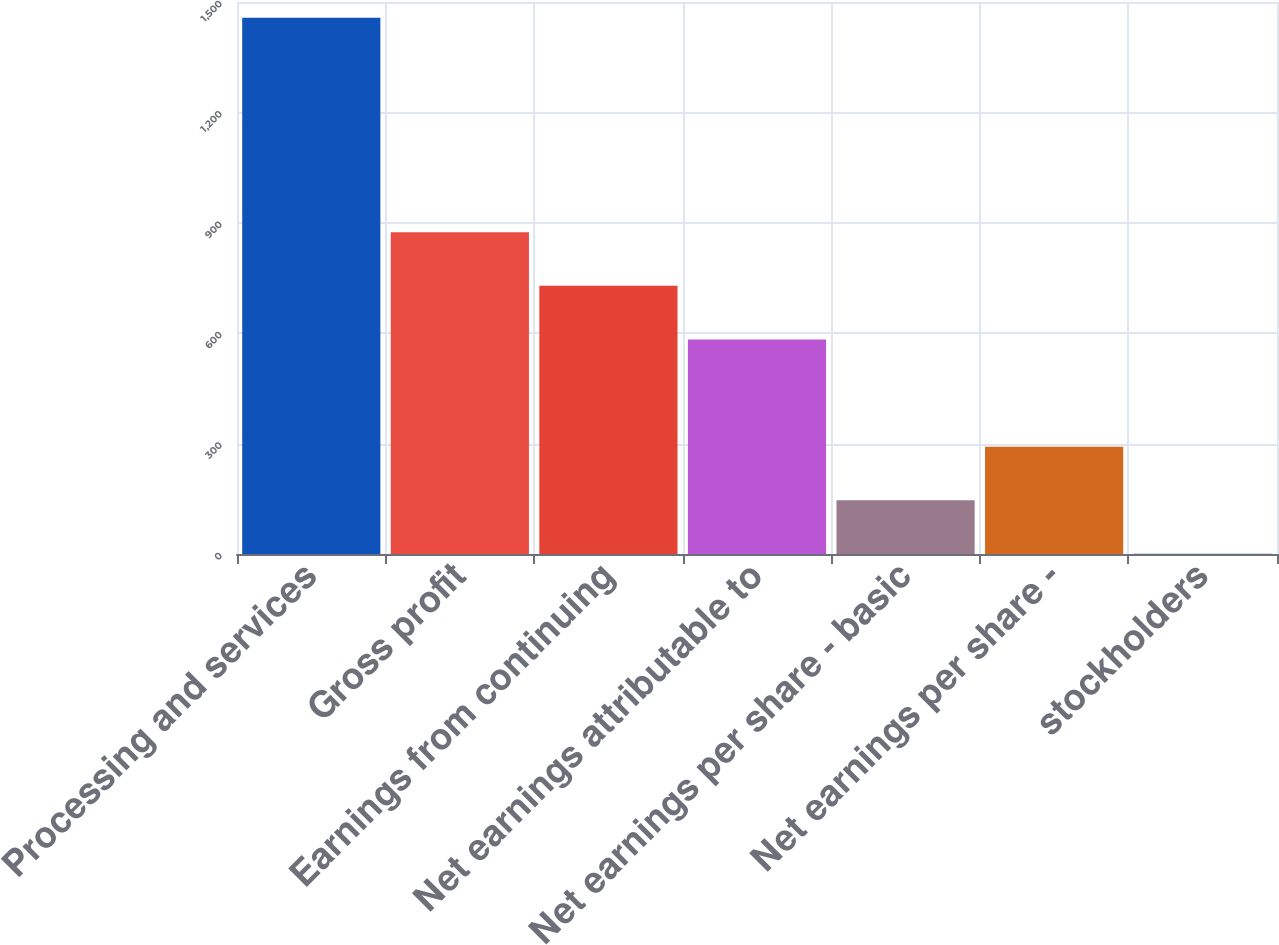Convert chart. <chart><loc_0><loc_0><loc_500><loc_500><bar_chart><fcel>Processing and services<fcel>Gross profit<fcel>Earnings from continuing<fcel>Net earnings attributable to<fcel>Net earnings per share - basic<fcel>Net earnings per share -<fcel>stockholders<nl><fcel>1457.2<fcel>874.48<fcel>728.8<fcel>583.12<fcel>146.08<fcel>291.76<fcel>0.4<nl></chart> 